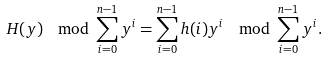<formula> <loc_0><loc_0><loc_500><loc_500>H ( y ) \, \mod \sum _ { i = 0 } ^ { n - 1 } y ^ { i } = \sum _ { i = 0 } ^ { n - 1 } h ( i ) y ^ { i } \, \mod \sum _ { i = 0 } ^ { n - 1 } y ^ { i } .</formula> 